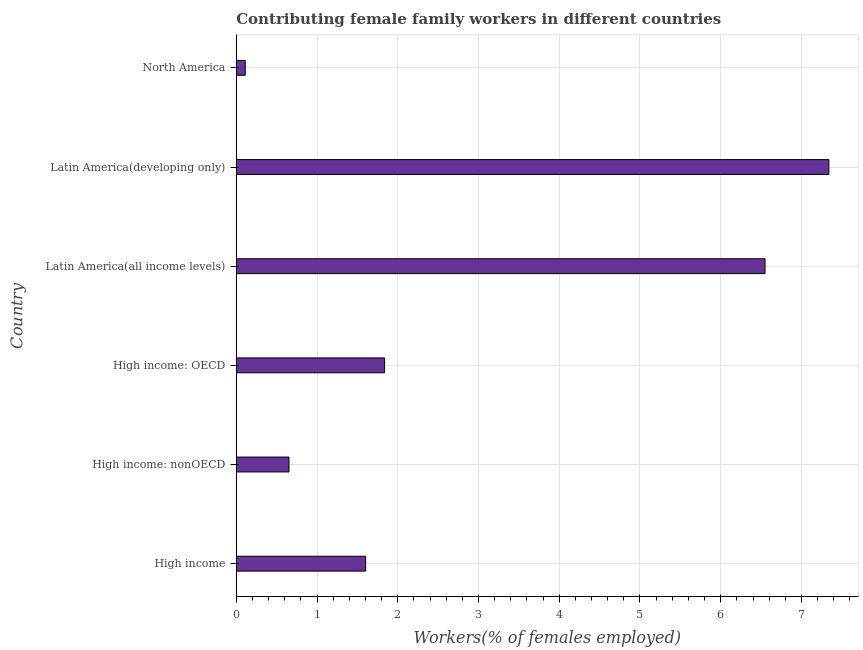Does the graph contain any zero values?
Your answer should be very brief. No. Does the graph contain grids?
Offer a very short reply. Yes. What is the title of the graph?
Ensure brevity in your answer.  Contributing female family workers in different countries. What is the label or title of the X-axis?
Keep it short and to the point. Workers(% of females employed). What is the label or title of the Y-axis?
Provide a short and direct response. Country. What is the contributing female family workers in North America?
Your answer should be compact. 0.11. Across all countries, what is the maximum contributing female family workers?
Give a very brief answer. 7.34. Across all countries, what is the minimum contributing female family workers?
Provide a short and direct response. 0.11. In which country was the contributing female family workers maximum?
Offer a very short reply. Latin America(developing only). In which country was the contributing female family workers minimum?
Your answer should be compact. North America. What is the sum of the contributing female family workers?
Your response must be concise. 18.09. What is the difference between the contributing female family workers in High income and High income: OECD?
Offer a very short reply. -0.23. What is the average contributing female family workers per country?
Your answer should be very brief. 3.02. What is the median contributing female family workers?
Give a very brief answer. 1.72. In how many countries, is the contributing female family workers greater than 1 %?
Ensure brevity in your answer.  4. What is the ratio of the contributing female family workers in High income to that in High income: nonOECD?
Give a very brief answer. 2.45. Is the difference between the contributing female family workers in High income: OECD and High income: nonOECD greater than the difference between any two countries?
Make the answer very short. No. What is the difference between the highest and the second highest contributing female family workers?
Ensure brevity in your answer.  0.79. Is the sum of the contributing female family workers in Latin America(all income levels) and North America greater than the maximum contributing female family workers across all countries?
Your response must be concise. No. What is the difference between the highest and the lowest contributing female family workers?
Offer a very short reply. 7.23. How many bars are there?
Give a very brief answer. 6. Are all the bars in the graph horizontal?
Keep it short and to the point. Yes. How many countries are there in the graph?
Your response must be concise. 6. Are the values on the major ticks of X-axis written in scientific E-notation?
Offer a terse response. No. What is the Workers(% of females employed) of High income?
Give a very brief answer. 1.6. What is the Workers(% of females employed) in High income: nonOECD?
Provide a short and direct response. 0.65. What is the Workers(% of females employed) of High income: OECD?
Your answer should be very brief. 1.84. What is the Workers(% of females employed) in Latin America(all income levels)?
Give a very brief answer. 6.55. What is the Workers(% of females employed) in Latin America(developing only)?
Your answer should be very brief. 7.34. What is the Workers(% of females employed) of North America?
Provide a short and direct response. 0.11. What is the difference between the Workers(% of females employed) in High income and High income: nonOECD?
Keep it short and to the point. 0.95. What is the difference between the Workers(% of females employed) in High income and High income: OECD?
Offer a very short reply. -0.23. What is the difference between the Workers(% of females employed) in High income and Latin America(all income levels)?
Ensure brevity in your answer.  -4.95. What is the difference between the Workers(% of females employed) in High income and Latin America(developing only)?
Your answer should be very brief. -5.74. What is the difference between the Workers(% of females employed) in High income and North America?
Offer a terse response. 1.49. What is the difference between the Workers(% of females employed) in High income: nonOECD and High income: OECD?
Your response must be concise. -1.18. What is the difference between the Workers(% of females employed) in High income: nonOECD and Latin America(all income levels)?
Keep it short and to the point. -5.9. What is the difference between the Workers(% of females employed) in High income: nonOECD and Latin America(developing only)?
Offer a terse response. -6.69. What is the difference between the Workers(% of females employed) in High income: nonOECD and North America?
Offer a terse response. 0.54. What is the difference between the Workers(% of females employed) in High income: OECD and Latin America(all income levels)?
Your answer should be very brief. -4.71. What is the difference between the Workers(% of females employed) in High income: OECD and Latin America(developing only)?
Ensure brevity in your answer.  -5.5. What is the difference between the Workers(% of females employed) in High income: OECD and North America?
Provide a succinct answer. 1.73. What is the difference between the Workers(% of females employed) in Latin America(all income levels) and Latin America(developing only)?
Your response must be concise. -0.79. What is the difference between the Workers(% of females employed) in Latin America(all income levels) and North America?
Keep it short and to the point. 6.44. What is the difference between the Workers(% of females employed) in Latin America(developing only) and North America?
Give a very brief answer. 7.23. What is the ratio of the Workers(% of females employed) in High income to that in High income: nonOECD?
Your response must be concise. 2.45. What is the ratio of the Workers(% of females employed) in High income to that in High income: OECD?
Your answer should be very brief. 0.87. What is the ratio of the Workers(% of females employed) in High income to that in Latin America(all income levels)?
Give a very brief answer. 0.24. What is the ratio of the Workers(% of females employed) in High income to that in Latin America(developing only)?
Ensure brevity in your answer.  0.22. What is the ratio of the Workers(% of females employed) in High income to that in North America?
Provide a short and direct response. 14.41. What is the ratio of the Workers(% of females employed) in High income: nonOECD to that in High income: OECD?
Offer a very short reply. 0.35. What is the ratio of the Workers(% of females employed) in High income: nonOECD to that in Latin America(developing only)?
Your response must be concise. 0.09. What is the ratio of the Workers(% of females employed) in High income: nonOECD to that in North America?
Give a very brief answer. 5.87. What is the ratio of the Workers(% of females employed) in High income: OECD to that in Latin America(all income levels)?
Keep it short and to the point. 0.28. What is the ratio of the Workers(% of females employed) in High income: OECD to that in Latin America(developing only)?
Make the answer very short. 0.25. What is the ratio of the Workers(% of females employed) in High income: OECD to that in North America?
Give a very brief answer. 16.52. What is the ratio of the Workers(% of females employed) in Latin America(all income levels) to that in Latin America(developing only)?
Your answer should be very brief. 0.89. What is the ratio of the Workers(% of females employed) in Latin America(all income levels) to that in North America?
Offer a very short reply. 58.9. What is the ratio of the Workers(% of females employed) in Latin America(developing only) to that in North America?
Your response must be concise. 66. 